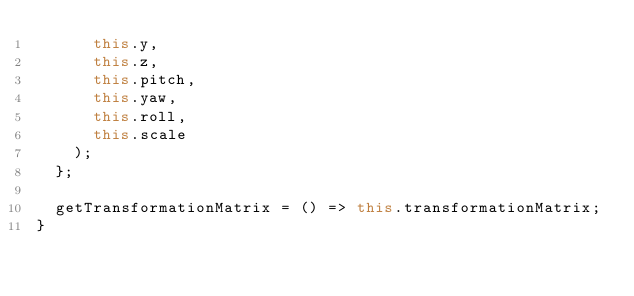Convert code to text. <code><loc_0><loc_0><loc_500><loc_500><_TypeScript_>      this.y,
      this.z,
      this.pitch,
      this.yaw,
      this.roll,
      this.scale
    );
  };

  getTransformationMatrix = () => this.transformationMatrix;
}
</code> 